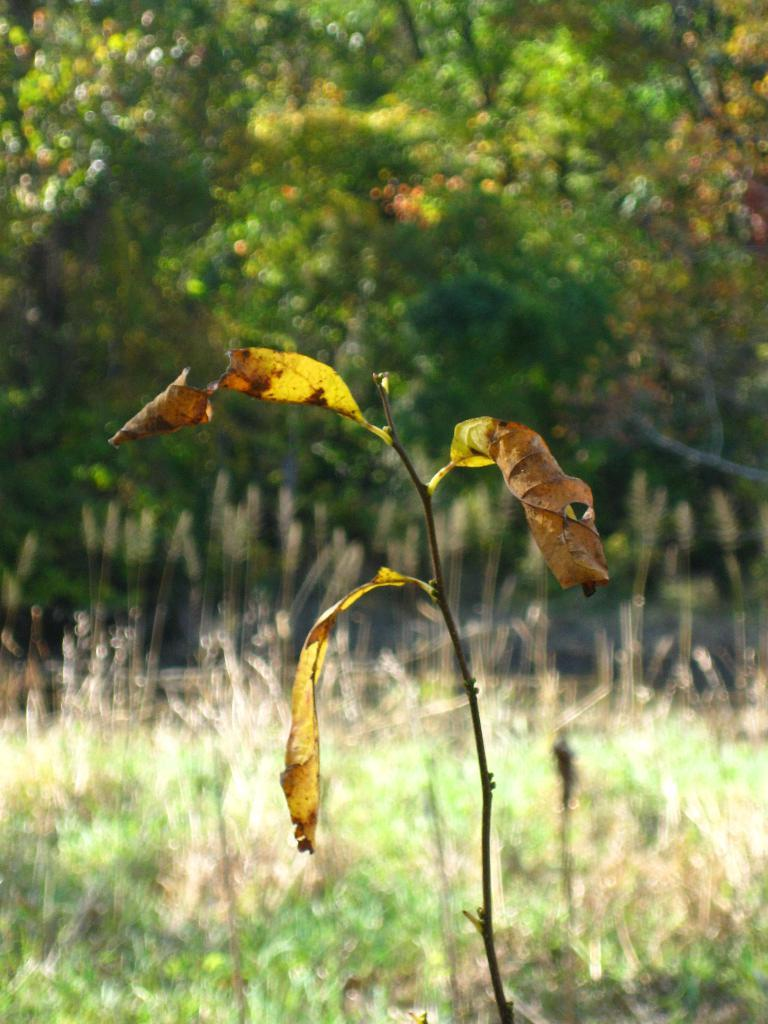What type of plant can be seen in the image? There is a plant with dried leaves in the image. What is on the ground in the image? There is grass on the ground in the image. What can be seen in the distance in the image? There are trees in the background of the image. What type of butter is being used to grease the trees in the image? There is no butter present in the image, and the trees are not being greased. 